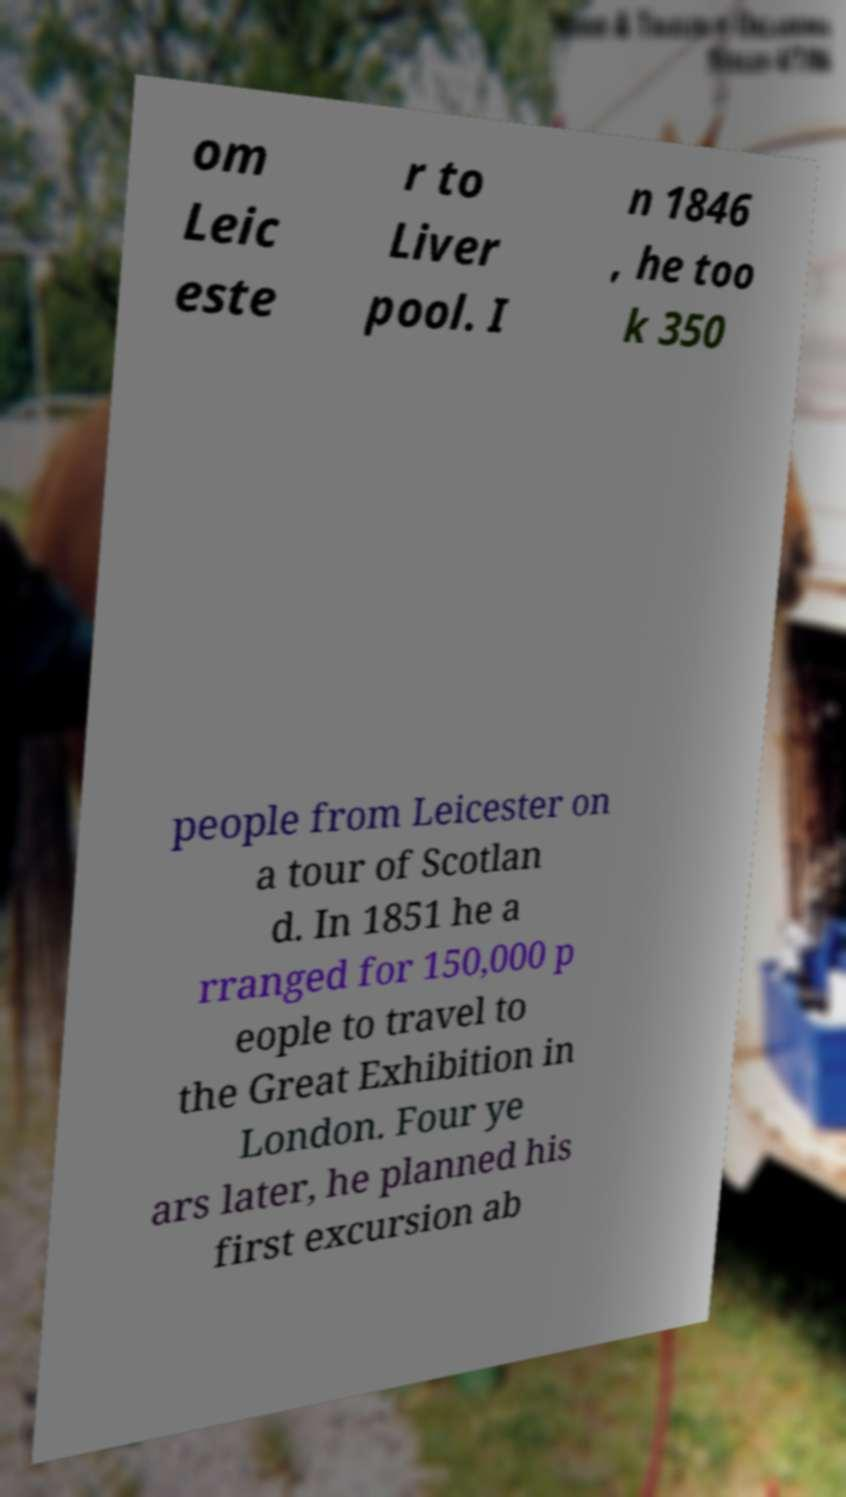For documentation purposes, I need the text within this image transcribed. Could you provide that? om Leic este r to Liver pool. I n 1846 , he too k 350 people from Leicester on a tour of Scotlan d. In 1851 he a rranged for 150,000 p eople to travel to the Great Exhibition in London. Four ye ars later, he planned his first excursion ab 